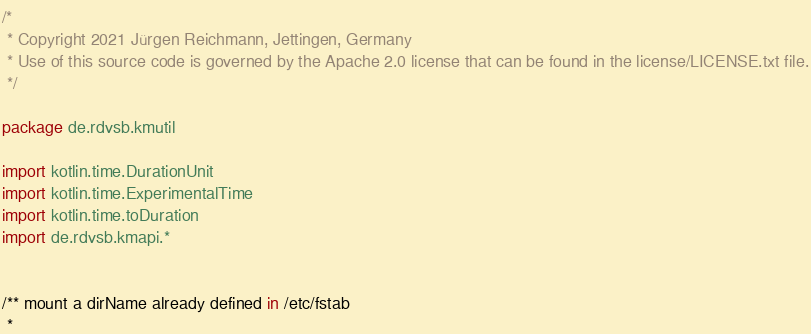<code> <loc_0><loc_0><loc_500><loc_500><_Kotlin_>/*
 * Copyright 2021 Jürgen Reichmann, Jettingen, Germany
 * Use of this source code is governed by the Apache 2.0 license that can be found in the license/LICENSE.txt file.
 */

package de.rdvsb.kmutil

import kotlin.time.DurationUnit
import kotlin.time.ExperimentalTime
import kotlin.time.toDuration
import de.rdvsb.kmapi.*


/** mount a dirName already defined in /etc/fstab
 *</code> 